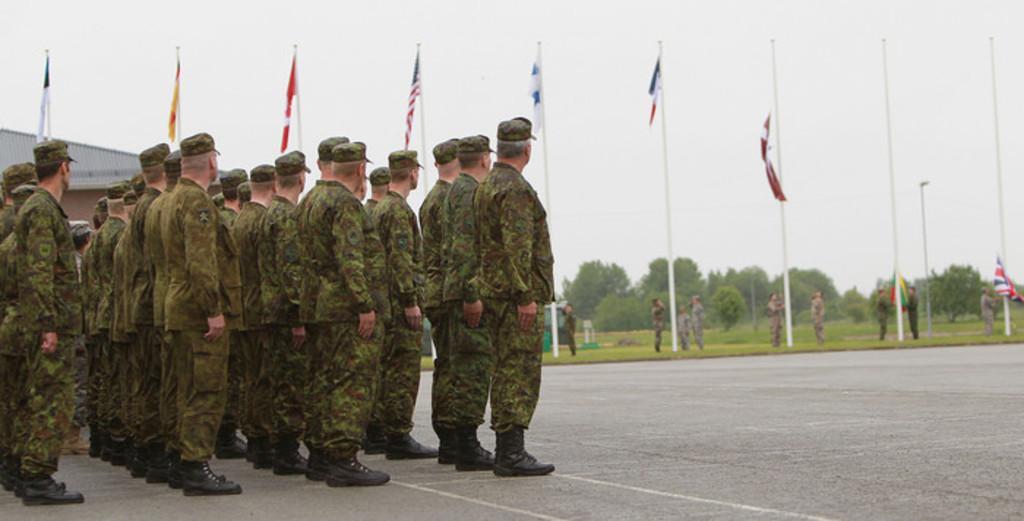How would you summarize this image in a sentence or two? In this image we can see people wearing uniforms. In the background there are flags, shade, trees, poles and sky. 